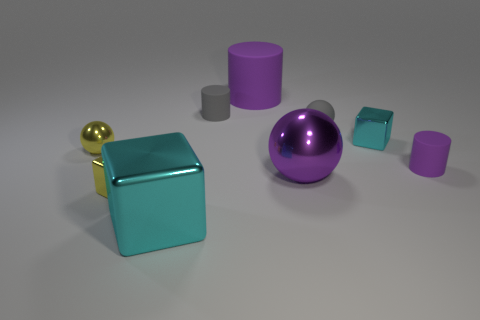There is a large metal thing that is to the right of the large cyan thing; is it the same color as the cylinder right of the big purple matte cylinder?
Provide a short and direct response. Yes. There is a big metal thing that is to the left of the purple ball; are there any tiny yellow blocks behind it?
Offer a very short reply. Yes. Are there fewer large shiny things that are in front of the large purple matte object than metallic things that are behind the big metallic block?
Offer a terse response. Yes. Is the material of the purple cylinder that is behind the tiny shiny ball the same as the purple thing right of the small cyan metallic block?
Ensure brevity in your answer.  Yes. What number of small things are either yellow things or cyan cubes?
Offer a terse response. 3. What shape is the large object that is the same material as the purple sphere?
Provide a succinct answer. Cube. Are there fewer rubber balls on the right side of the small cyan metallic block than large metallic blocks?
Give a very brief answer. Yes. Does the big purple metallic object have the same shape as the big purple rubber object?
Provide a short and direct response. No. How many matte things are large purple cylinders or yellow blocks?
Offer a very short reply. 1. Are there any cyan blocks of the same size as the yellow metallic cube?
Give a very brief answer. Yes. 